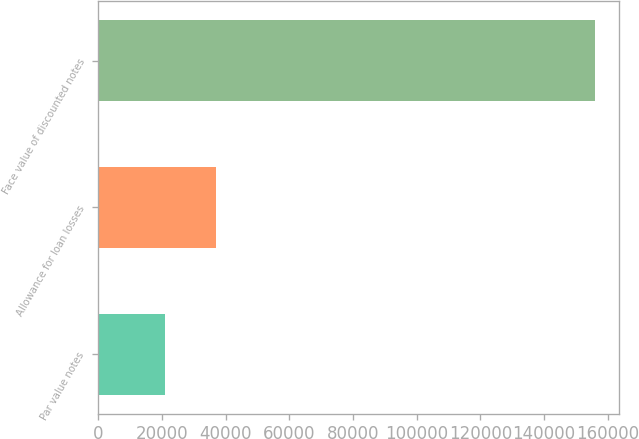<chart> <loc_0><loc_0><loc_500><loc_500><bar_chart><fcel>Par value notes<fcel>Allowance for loan losses<fcel>Face value of discounted notes<nl><fcel>20862<fcel>37061<fcel>155848<nl></chart> 